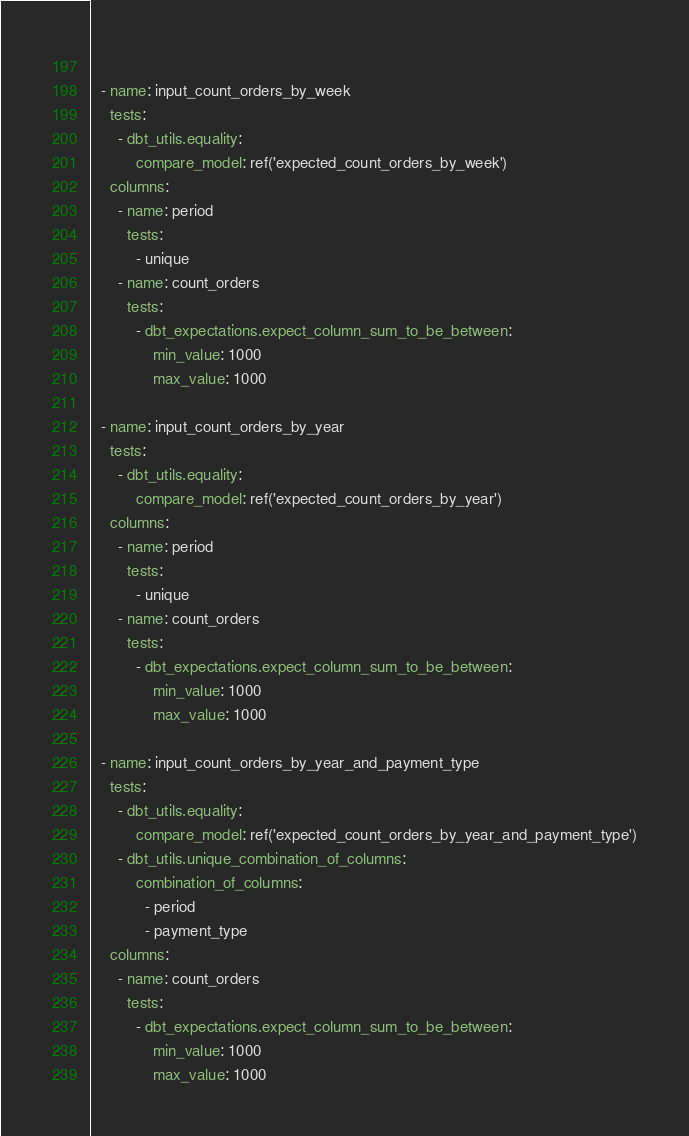<code> <loc_0><loc_0><loc_500><loc_500><_YAML_>              
  - name: input_count_orders_by_week
    tests:
      - dbt_utils.equality:
          compare_model: ref('expected_count_orders_by_week')
    columns: 
      - name: period
        tests:
          - unique
      - name: count_orders
        tests:
          - dbt_expectations.expect_column_sum_to_be_between:
              min_value: 1000
              max_value: 1000

  - name: input_count_orders_by_year
    tests:
      - dbt_utils.equality:
          compare_model: ref('expected_count_orders_by_year')
    columns: 
      - name: period
        tests:
          - unique
      - name: count_orders
        tests:
          - dbt_expectations.expect_column_sum_to_be_between:
              min_value: 1000
              max_value: 1000
              
  - name: input_count_orders_by_year_and_payment_type
    tests:
      - dbt_utils.equality:
          compare_model: ref('expected_count_orders_by_year_and_payment_type')
      - dbt_utils.unique_combination_of_columns: 
          combination_of_columns: 
            - period
            - payment_type
    columns: 
      - name: count_orders
        tests:
          - dbt_expectations.expect_column_sum_to_be_between:
              min_value: 1000
              max_value: 1000</code> 